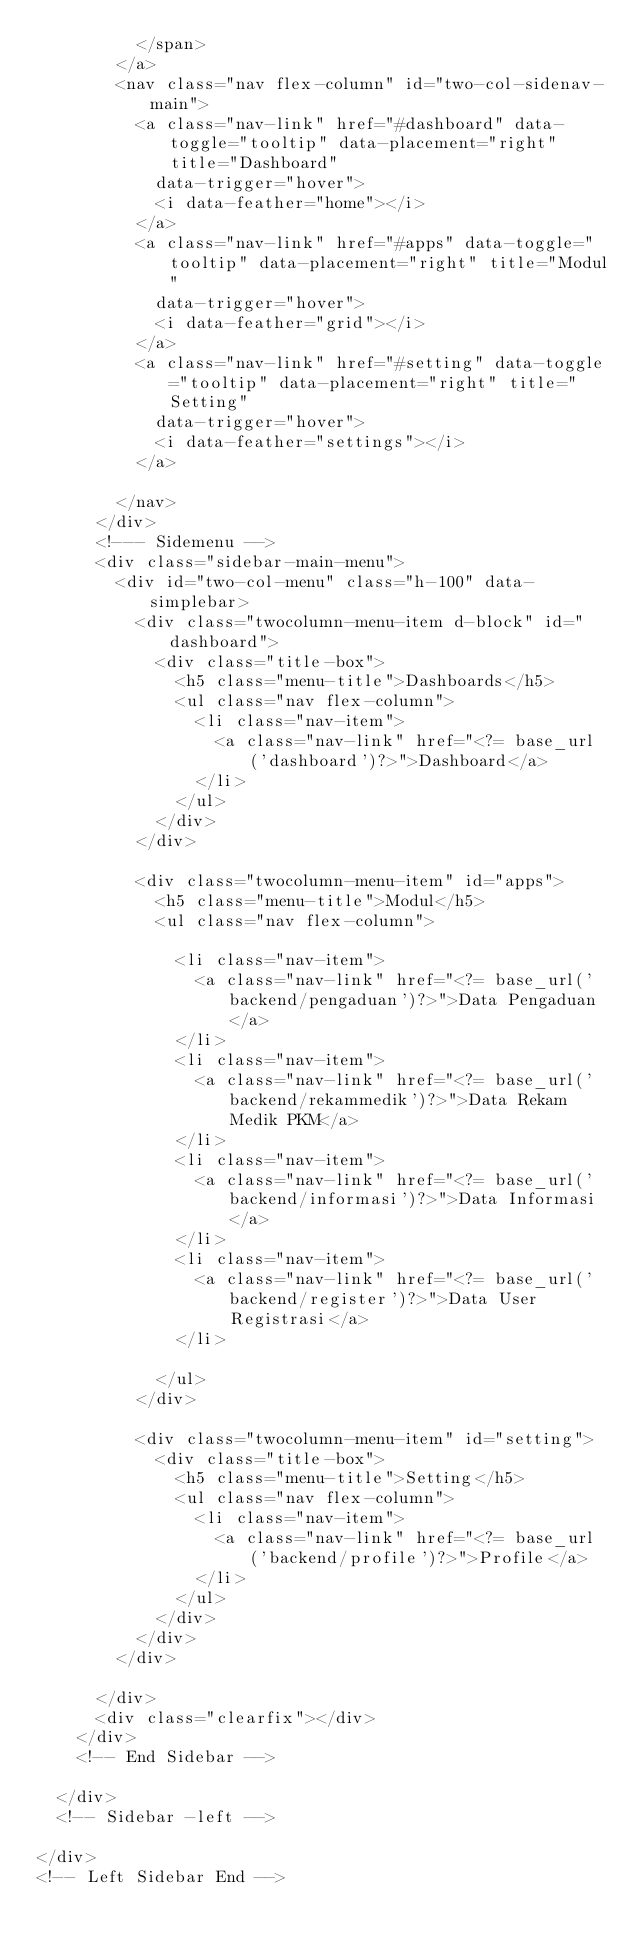<code> <loc_0><loc_0><loc_500><loc_500><_PHP_>          </span>
        </a>
        <nav class="nav flex-column" id="two-col-sidenav-main">
          <a class="nav-link" href="#dashboard" data-toggle="tooltip" data-placement="right" title="Dashboard"
            data-trigger="hover">
            <i data-feather="home"></i>
          </a>
          <a class="nav-link" href="#apps" data-toggle="tooltip" data-placement="right" title="Modul"
            data-trigger="hover">
            <i data-feather="grid"></i>
          </a>
          <a class="nav-link" href="#setting" data-toggle="tooltip" data-placement="right" title="Setting"
            data-trigger="hover">
            <i data-feather="settings"></i>
          </a>

        </nav>
      </div>
      <!--- Sidemenu -->
      <div class="sidebar-main-menu">
        <div id="two-col-menu" class="h-100" data-simplebar>
          <div class="twocolumn-menu-item d-block" id="dashboard">
            <div class="title-box">
              <h5 class="menu-title">Dashboards</h5>
              <ul class="nav flex-column">
                <li class="nav-item">
                  <a class="nav-link" href="<?= base_url('dashboard')?>">Dashboard</a>
                </li>
              </ul>
            </div>
          </div>

          <div class="twocolumn-menu-item" id="apps">
            <h5 class="menu-title">Modul</h5>
            <ul class="nav flex-column">

              <li class="nav-item">
                <a class="nav-link" href="<?= base_url('backend/pengaduan')?>">Data Pengaduan</a>
              </li>
              <li class="nav-item">
                <a class="nav-link" href="<?= base_url('backend/rekammedik')?>">Data Rekam Medik PKM</a>
              </li>
              <li class="nav-item">
                <a class="nav-link" href="<?= base_url('backend/informasi')?>">Data Informasi</a>
              </li>
              <li class="nav-item">
                <a class="nav-link" href="<?= base_url('backend/register')?>">Data User Registrasi</a>
              </li>

            </ul>
          </div>

          <div class="twocolumn-menu-item" id="setting">
            <div class="title-box">
              <h5 class="menu-title">Setting</h5>
              <ul class="nav flex-column">
                <li class="nav-item">
                  <a class="nav-link" href="<?= base_url('backend/profile')?>">Profile</a>
                </li>
              </ul>
            </div>
          </div>
        </div>

      </div>
      <div class="clearfix"></div>
    </div>
    <!-- End Sidebar -->

  </div>
  <!-- Sidebar -left -->

</div>
<!-- Left Sidebar End --></code> 